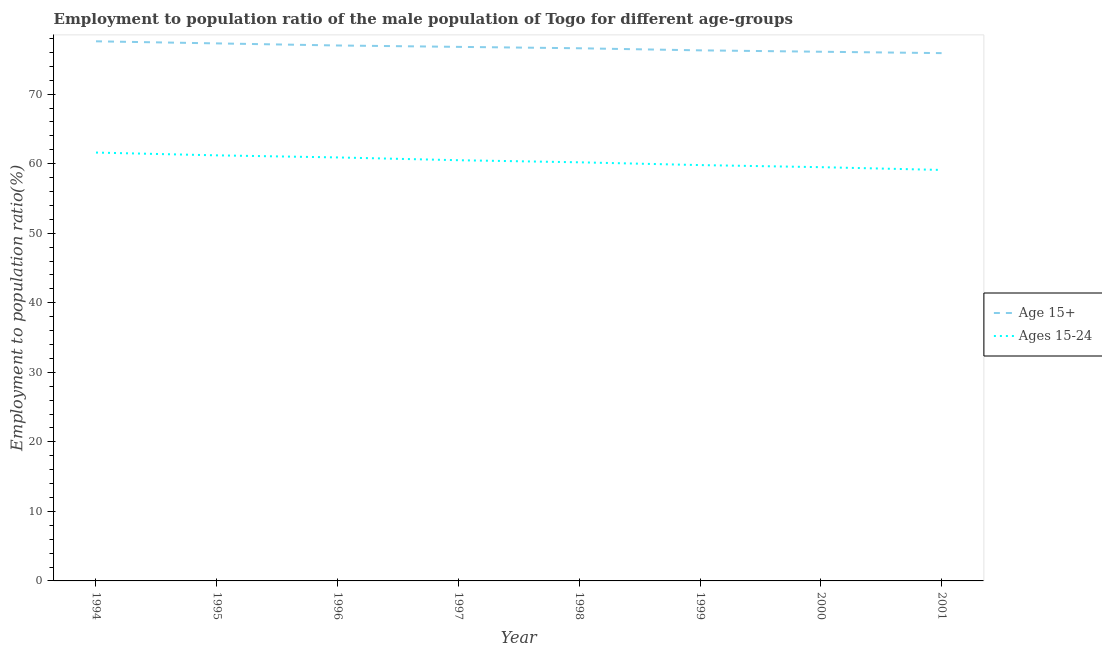Does the line corresponding to employment to population ratio(age 15+) intersect with the line corresponding to employment to population ratio(age 15-24)?
Your answer should be compact. No. Is the number of lines equal to the number of legend labels?
Ensure brevity in your answer.  Yes. What is the employment to population ratio(age 15-24) in 2000?
Give a very brief answer. 59.5. Across all years, what is the maximum employment to population ratio(age 15+)?
Your answer should be very brief. 77.6. Across all years, what is the minimum employment to population ratio(age 15-24)?
Ensure brevity in your answer.  59.1. What is the total employment to population ratio(age 15-24) in the graph?
Your answer should be very brief. 482.8. What is the difference between the employment to population ratio(age 15-24) in 1998 and that in 1999?
Your answer should be compact. 0.4. What is the difference between the employment to population ratio(age 15+) in 2001 and the employment to population ratio(age 15-24) in 2000?
Make the answer very short. 16.4. What is the average employment to population ratio(age 15+) per year?
Provide a succinct answer. 76.7. In the year 1999, what is the difference between the employment to population ratio(age 15-24) and employment to population ratio(age 15+)?
Provide a short and direct response. -16.5. In how many years, is the employment to population ratio(age 15+) greater than 8 %?
Offer a terse response. 8. What is the ratio of the employment to population ratio(age 15+) in 1996 to that in 1998?
Your response must be concise. 1.01. What is the difference between the highest and the second highest employment to population ratio(age 15+)?
Offer a terse response. 0.3. Is the employment to population ratio(age 15-24) strictly less than the employment to population ratio(age 15+) over the years?
Give a very brief answer. Yes. How many years are there in the graph?
Offer a terse response. 8. What is the difference between two consecutive major ticks on the Y-axis?
Offer a very short reply. 10. Are the values on the major ticks of Y-axis written in scientific E-notation?
Your answer should be very brief. No. Does the graph contain any zero values?
Provide a short and direct response. No. Where does the legend appear in the graph?
Your response must be concise. Center right. How are the legend labels stacked?
Your answer should be very brief. Vertical. What is the title of the graph?
Offer a terse response. Employment to population ratio of the male population of Togo for different age-groups. Does "Merchandise imports" appear as one of the legend labels in the graph?
Ensure brevity in your answer.  No. What is the label or title of the Y-axis?
Provide a succinct answer. Employment to population ratio(%). What is the Employment to population ratio(%) of Age 15+ in 1994?
Offer a very short reply. 77.6. What is the Employment to population ratio(%) in Ages 15-24 in 1994?
Offer a terse response. 61.6. What is the Employment to population ratio(%) of Age 15+ in 1995?
Give a very brief answer. 77.3. What is the Employment to population ratio(%) of Ages 15-24 in 1995?
Give a very brief answer. 61.2. What is the Employment to population ratio(%) in Age 15+ in 1996?
Provide a short and direct response. 77. What is the Employment to population ratio(%) in Ages 15-24 in 1996?
Provide a short and direct response. 60.9. What is the Employment to population ratio(%) in Age 15+ in 1997?
Keep it short and to the point. 76.8. What is the Employment to population ratio(%) in Ages 15-24 in 1997?
Offer a very short reply. 60.5. What is the Employment to population ratio(%) in Age 15+ in 1998?
Make the answer very short. 76.6. What is the Employment to population ratio(%) in Ages 15-24 in 1998?
Provide a succinct answer. 60.2. What is the Employment to population ratio(%) in Age 15+ in 1999?
Keep it short and to the point. 76.3. What is the Employment to population ratio(%) in Ages 15-24 in 1999?
Your answer should be compact. 59.8. What is the Employment to population ratio(%) in Age 15+ in 2000?
Provide a succinct answer. 76.1. What is the Employment to population ratio(%) in Ages 15-24 in 2000?
Provide a succinct answer. 59.5. What is the Employment to population ratio(%) in Age 15+ in 2001?
Your response must be concise. 75.9. What is the Employment to population ratio(%) of Ages 15-24 in 2001?
Provide a succinct answer. 59.1. Across all years, what is the maximum Employment to population ratio(%) of Age 15+?
Provide a short and direct response. 77.6. Across all years, what is the maximum Employment to population ratio(%) of Ages 15-24?
Your answer should be very brief. 61.6. Across all years, what is the minimum Employment to population ratio(%) of Age 15+?
Give a very brief answer. 75.9. Across all years, what is the minimum Employment to population ratio(%) in Ages 15-24?
Your answer should be very brief. 59.1. What is the total Employment to population ratio(%) in Age 15+ in the graph?
Offer a very short reply. 613.6. What is the total Employment to population ratio(%) in Ages 15-24 in the graph?
Offer a very short reply. 482.8. What is the difference between the Employment to population ratio(%) in Age 15+ in 1994 and that in 1995?
Ensure brevity in your answer.  0.3. What is the difference between the Employment to population ratio(%) in Ages 15-24 in 1994 and that in 1995?
Your answer should be compact. 0.4. What is the difference between the Employment to population ratio(%) of Ages 15-24 in 1994 and that in 1996?
Make the answer very short. 0.7. What is the difference between the Employment to population ratio(%) of Ages 15-24 in 1994 and that in 1998?
Provide a short and direct response. 1.4. What is the difference between the Employment to population ratio(%) in Age 15+ in 1994 and that in 1999?
Offer a terse response. 1.3. What is the difference between the Employment to population ratio(%) in Ages 15-24 in 1994 and that in 1999?
Your answer should be very brief. 1.8. What is the difference between the Employment to population ratio(%) in Ages 15-24 in 1994 and that in 2000?
Provide a short and direct response. 2.1. What is the difference between the Employment to population ratio(%) of Age 15+ in 1994 and that in 2001?
Offer a terse response. 1.7. What is the difference between the Employment to population ratio(%) in Ages 15-24 in 1994 and that in 2001?
Make the answer very short. 2.5. What is the difference between the Employment to population ratio(%) of Age 15+ in 1995 and that in 1997?
Offer a terse response. 0.5. What is the difference between the Employment to population ratio(%) in Age 15+ in 1995 and that in 1998?
Keep it short and to the point. 0.7. What is the difference between the Employment to population ratio(%) of Ages 15-24 in 1995 and that in 1999?
Provide a short and direct response. 1.4. What is the difference between the Employment to population ratio(%) of Age 15+ in 1996 and that in 1999?
Make the answer very short. 0.7. What is the difference between the Employment to population ratio(%) in Ages 15-24 in 1996 and that in 2000?
Provide a succinct answer. 1.4. What is the difference between the Employment to population ratio(%) in Ages 15-24 in 1997 and that in 1998?
Your answer should be very brief. 0.3. What is the difference between the Employment to population ratio(%) in Age 15+ in 1997 and that in 1999?
Your answer should be compact. 0.5. What is the difference between the Employment to population ratio(%) of Ages 15-24 in 1997 and that in 1999?
Ensure brevity in your answer.  0.7. What is the difference between the Employment to population ratio(%) of Ages 15-24 in 1997 and that in 2000?
Offer a very short reply. 1. What is the difference between the Employment to population ratio(%) of Age 15+ in 1997 and that in 2001?
Offer a terse response. 0.9. What is the difference between the Employment to population ratio(%) in Ages 15-24 in 1997 and that in 2001?
Give a very brief answer. 1.4. What is the difference between the Employment to population ratio(%) of Ages 15-24 in 1998 and that in 2000?
Make the answer very short. 0.7. What is the difference between the Employment to population ratio(%) of Age 15+ in 1998 and that in 2001?
Make the answer very short. 0.7. What is the difference between the Employment to population ratio(%) in Ages 15-24 in 1998 and that in 2001?
Your response must be concise. 1.1. What is the difference between the Employment to population ratio(%) in Age 15+ in 1999 and that in 2001?
Keep it short and to the point. 0.4. What is the difference between the Employment to population ratio(%) in Age 15+ in 2000 and that in 2001?
Give a very brief answer. 0.2. What is the difference between the Employment to population ratio(%) in Age 15+ in 1994 and the Employment to population ratio(%) in Ages 15-24 in 1995?
Your answer should be very brief. 16.4. What is the difference between the Employment to population ratio(%) of Age 15+ in 1994 and the Employment to population ratio(%) of Ages 15-24 in 1996?
Your response must be concise. 16.7. What is the difference between the Employment to population ratio(%) in Age 15+ in 1994 and the Employment to population ratio(%) in Ages 15-24 in 1997?
Your answer should be very brief. 17.1. What is the difference between the Employment to population ratio(%) of Age 15+ in 1995 and the Employment to population ratio(%) of Ages 15-24 in 1997?
Provide a short and direct response. 16.8. What is the difference between the Employment to population ratio(%) of Age 15+ in 1995 and the Employment to population ratio(%) of Ages 15-24 in 1998?
Your answer should be very brief. 17.1. What is the difference between the Employment to population ratio(%) in Age 15+ in 1995 and the Employment to population ratio(%) in Ages 15-24 in 1999?
Offer a very short reply. 17.5. What is the difference between the Employment to population ratio(%) in Age 15+ in 1995 and the Employment to population ratio(%) in Ages 15-24 in 2000?
Your answer should be very brief. 17.8. What is the difference between the Employment to population ratio(%) of Age 15+ in 1995 and the Employment to population ratio(%) of Ages 15-24 in 2001?
Your response must be concise. 18.2. What is the difference between the Employment to population ratio(%) of Age 15+ in 1996 and the Employment to population ratio(%) of Ages 15-24 in 1997?
Offer a terse response. 16.5. What is the difference between the Employment to population ratio(%) in Age 15+ in 1996 and the Employment to population ratio(%) in Ages 15-24 in 1998?
Provide a short and direct response. 16.8. What is the difference between the Employment to population ratio(%) in Age 15+ in 1996 and the Employment to population ratio(%) in Ages 15-24 in 1999?
Your answer should be compact. 17.2. What is the difference between the Employment to population ratio(%) of Age 15+ in 1997 and the Employment to population ratio(%) of Ages 15-24 in 1999?
Offer a terse response. 17. What is the difference between the Employment to population ratio(%) of Age 15+ in 1998 and the Employment to population ratio(%) of Ages 15-24 in 1999?
Offer a terse response. 16.8. What is the difference between the Employment to population ratio(%) in Age 15+ in 1998 and the Employment to population ratio(%) in Ages 15-24 in 2000?
Make the answer very short. 17.1. What is the difference between the Employment to population ratio(%) in Age 15+ in 2000 and the Employment to population ratio(%) in Ages 15-24 in 2001?
Offer a terse response. 17. What is the average Employment to population ratio(%) of Age 15+ per year?
Your response must be concise. 76.7. What is the average Employment to population ratio(%) in Ages 15-24 per year?
Your answer should be very brief. 60.35. In the year 1994, what is the difference between the Employment to population ratio(%) of Age 15+ and Employment to population ratio(%) of Ages 15-24?
Your answer should be compact. 16. In the year 1995, what is the difference between the Employment to population ratio(%) of Age 15+ and Employment to population ratio(%) of Ages 15-24?
Keep it short and to the point. 16.1. In the year 1996, what is the difference between the Employment to population ratio(%) of Age 15+ and Employment to population ratio(%) of Ages 15-24?
Keep it short and to the point. 16.1. In the year 1998, what is the difference between the Employment to population ratio(%) of Age 15+ and Employment to population ratio(%) of Ages 15-24?
Keep it short and to the point. 16.4. In the year 1999, what is the difference between the Employment to population ratio(%) of Age 15+ and Employment to population ratio(%) of Ages 15-24?
Your response must be concise. 16.5. In the year 2000, what is the difference between the Employment to population ratio(%) in Age 15+ and Employment to population ratio(%) in Ages 15-24?
Provide a short and direct response. 16.6. In the year 2001, what is the difference between the Employment to population ratio(%) in Age 15+ and Employment to population ratio(%) in Ages 15-24?
Offer a terse response. 16.8. What is the ratio of the Employment to population ratio(%) of Ages 15-24 in 1994 to that in 1995?
Your response must be concise. 1.01. What is the ratio of the Employment to population ratio(%) of Ages 15-24 in 1994 to that in 1996?
Your answer should be very brief. 1.01. What is the ratio of the Employment to population ratio(%) of Age 15+ in 1994 to that in 1997?
Make the answer very short. 1.01. What is the ratio of the Employment to population ratio(%) in Ages 15-24 in 1994 to that in 1997?
Your response must be concise. 1.02. What is the ratio of the Employment to population ratio(%) of Age 15+ in 1994 to that in 1998?
Offer a terse response. 1.01. What is the ratio of the Employment to population ratio(%) of Ages 15-24 in 1994 to that in 1998?
Offer a terse response. 1.02. What is the ratio of the Employment to population ratio(%) in Age 15+ in 1994 to that in 1999?
Ensure brevity in your answer.  1.02. What is the ratio of the Employment to population ratio(%) in Ages 15-24 in 1994 to that in 1999?
Provide a short and direct response. 1.03. What is the ratio of the Employment to population ratio(%) in Age 15+ in 1994 to that in 2000?
Provide a short and direct response. 1.02. What is the ratio of the Employment to population ratio(%) of Ages 15-24 in 1994 to that in 2000?
Your answer should be compact. 1.04. What is the ratio of the Employment to population ratio(%) in Age 15+ in 1994 to that in 2001?
Provide a short and direct response. 1.02. What is the ratio of the Employment to population ratio(%) in Ages 15-24 in 1994 to that in 2001?
Give a very brief answer. 1.04. What is the ratio of the Employment to population ratio(%) in Age 15+ in 1995 to that in 1996?
Provide a short and direct response. 1. What is the ratio of the Employment to population ratio(%) in Age 15+ in 1995 to that in 1997?
Make the answer very short. 1.01. What is the ratio of the Employment to population ratio(%) of Ages 15-24 in 1995 to that in 1997?
Your response must be concise. 1.01. What is the ratio of the Employment to population ratio(%) in Age 15+ in 1995 to that in 1998?
Provide a succinct answer. 1.01. What is the ratio of the Employment to population ratio(%) of Ages 15-24 in 1995 to that in 1998?
Offer a very short reply. 1.02. What is the ratio of the Employment to population ratio(%) in Age 15+ in 1995 to that in 1999?
Your response must be concise. 1.01. What is the ratio of the Employment to population ratio(%) of Ages 15-24 in 1995 to that in 1999?
Ensure brevity in your answer.  1.02. What is the ratio of the Employment to population ratio(%) of Age 15+ in 1995 to that in 2000?
Give a very brief answer. 1.02. What is the ratio of the Employment to population ratio(%) of Ages 15-24 in 1995 to that in 2000?
Ensure brevity in your answer.  1.03. What is the ratio of the Employment to population ratio(%) in Age 15+ in 1995 to that in 2001?
Offer a very short reply. 1.02. What is the ratio of the Employment to population ratio(%) in Ages 15-24 in 1995 to that in 2001?
Provide a succinct answer. 1.04. What is the ratio of the Employment to population ratio(%) of Ages 15-24 in 1996 to that in 1997?
Ensure brevity in your answer.  1.01. What is the ratio of the Employment to population ratio(%) in Age 15+ in 1996 to that in 1998?
Your answer should be compact. 1.01. What is the ratio of the Employment to population ratio(%) of Ages 15-24 in 1996 to that in 1998?
Give a very brief answer. 1.01. What is the ratio of the Employment to population ratio(%) in Age 15+ in 1996 to that in 1999?
Give a very brief answer. 1.01. What is the ratio of the Employment to population ratio(%) in Ages 15-24 in 1996 to that in 1999?
Your response must be concise. 1.02. What is the ratio of the Employment to population ratio(%) of Age 15+ in 1996 to that in 2000?
Offer a very short reply. 1.01. What is the ratio of the Employment to population ratio(%) of Ages 15-24 in 1996 to that in 2000?
Make the answer very short. 1.02. What is the ratio of the Employment to population ratio(%) in Age 15+ in 1996 to that in 2001?
Keep it short and to the point. 1.01. What is the ratio of the Employment to population ratio(%) of Ages 15-24 in 1996 to that in 2001?
Keep it short and to the point. 1.03. What is the ratio of the Employment to population ratio(%) of Age 15+ in 1997 to that in 1999?
Your answer should be very brief. 1.01. What is the ratio of the Employment to population ratio(%) of Ages 15-24 in 1997 to that in 1999?
Make the answer very short. 1.01. What is the ratio of the Employment to population ratio(%) of Age 15+ in 1997 to that in 2000?
Your answer should be very brief. 1.01. What is the ratio of the Employment to population ratio(%) in Ages 15-24 in 1997 to that in 2000?
Provide a short and direct response. 1.02. What is the ratio of the Employment to population ratio(%) in Age 15+ in 1997 to that in 2001?
Ensure brevity in your answer.  1.01. What is the ratio of the Employment to population ratio(%) in Ages 15-24 in 1997 to that in 2001?
Offer a terse response. 1.02. What is the ratio of the Employment to population ratio(%) in Age 15+ in 1998 to that in 1999?
Your answer should be compact. 1. What is the ratio of the Employment to population ratio(%) of Age 15+ in 1998 to that in 2000?
Your answer should be compact. 1.01. What is the ratio of the Employment to population ratio(%) in Ages 15-24 in 1998 to that in 2000?
Give a very brief answer. 1.01. What is the ratio of the Employment to population ratio(%) in Age 15+ in 1998 to that in 2001?
Provide a short and direct response. 1.01. What is the ratio of the Employment to population ratio(%) of Ages 15-24 in 1998 to that in 2001?
Your answer should be compact. 1.02. What is the ratio of the Employment to population ratio(%) in Age 15+ in 1999 to that in 2001?
Offer a terse response. 1.01. What is the ratio of the Employment to population ratio(%) of Ages 15-24 in 1999 to that in 2001?
Offer a terse response. 1.01. What is the ratio of the Employment to population ratio(%) in Age 15+ in 2000 to that in 2001?
Provide a succinct answer. 1. What is the ratio of the Employment to population ratio(%) in Ages 15-24 in 2000 to that in 2001?
Make the answer very short. 1.01. What is the difference between the highest and the second highest Employment to population ratio(%) in Age 15+?
Make the answer very short. 0.3. What is the difference between the highest and the lowest Employment to population ratio(%) of Age 15+?
Give a very brief answer. 1.7. 